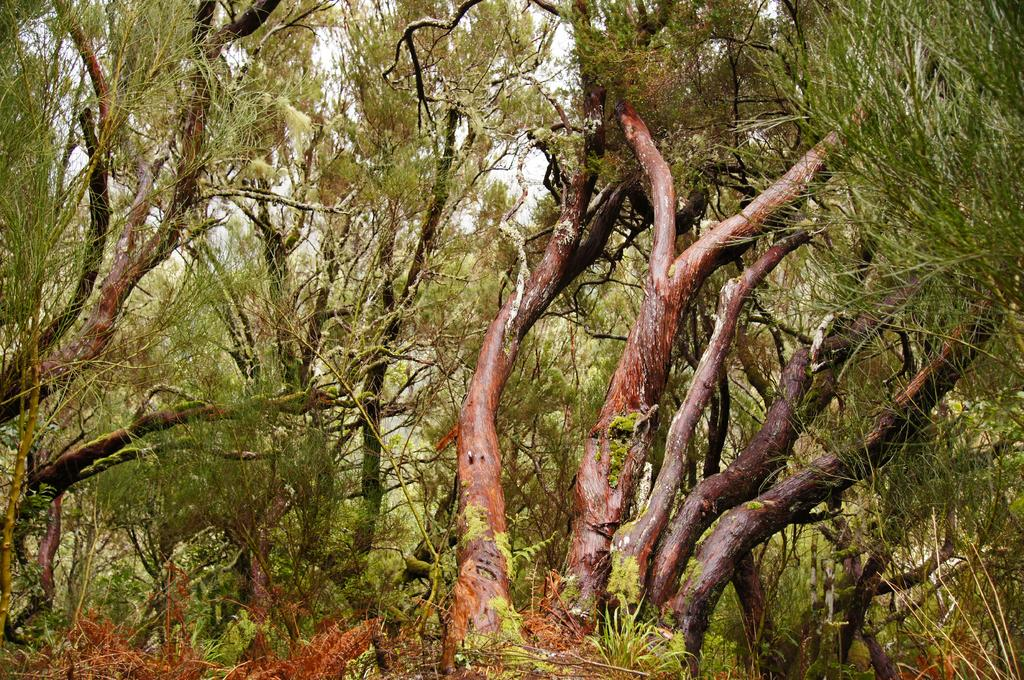What is the main subject of the image? There is a painting in the image. What is depicted in the painting? The painting depicts trees. What type of food is being served in the lunchroom in the image? There is no lunchroom or food present in the image; it only features a painting of trees. What month is it in the image? The image does not provide any information about the month or time of year. 